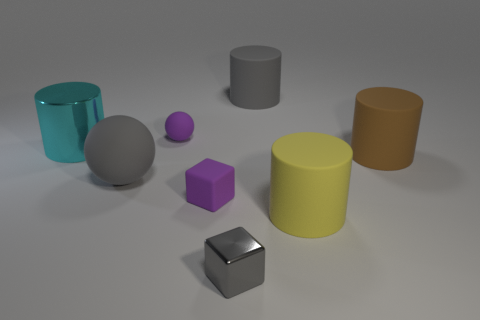There is a small purple object that is in front of the large rubber object left of the purple matte object that is in front of the big cyan thing; what is its material?
Offer a terse response. Rubber. Is the size of the object that is behind the tiny rubber sphere the same as the gray object left of the small gray object?
Offer a very short reply. Yes. How many other objects are the same material as the cyan thing?
Ensure brevity in your answer.  1. What number of metal things are big brown cylinders or yellow things?
Ensure brevity in your answer.  0. Is the number of large yellow objects less than the number of cubes?
Your answer should be very brief. Yes. There is a gray sphere; is its size the same as the metal object that is on the left side of the gray metal cube?
Give a very brief answer. Yes. The purple matte block is what size?
Keep it short and to the point. Small. Is the number of purple balls on the right side of the tiny gray cube less than the number of tiny blue metallic objects?
Give a very brief answer. No. Do the metallic cube and the cyan object have the same size?
Provide a succinct answer. No. There is a small cube that is the same material as the gray cylinder; what color is it?
Give a very brief answer. Purple. 